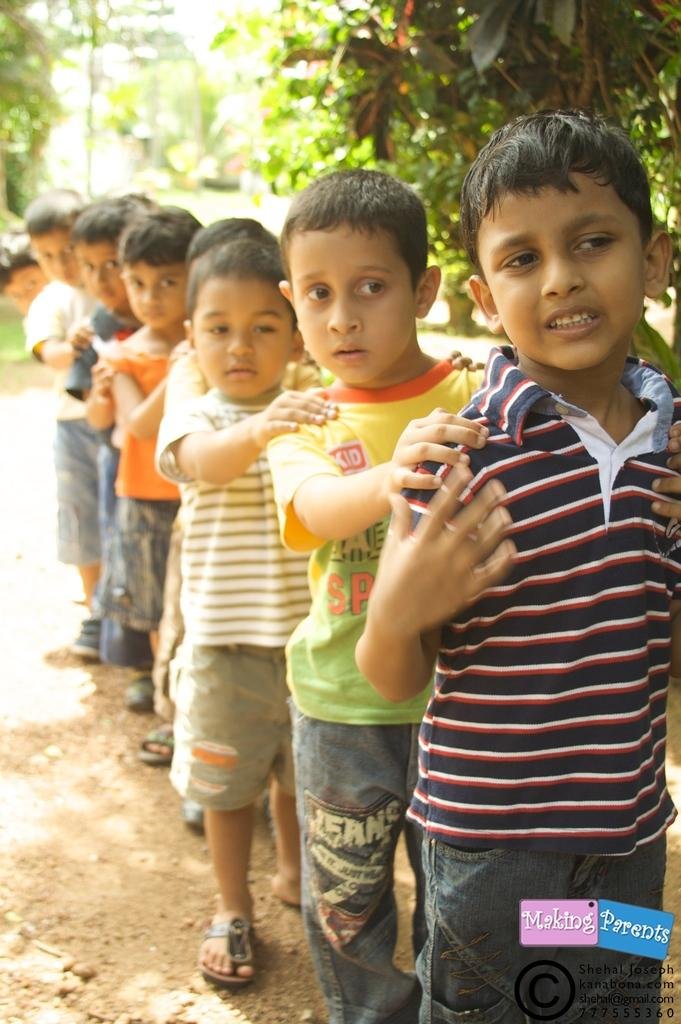What is the main subject of the image? The main subject of the image is a line of boys. Can you describe the positioning of the boys in the image? The boys are standing in a line. What can be seen in the background of the image? Trees are visible at the top of the image. What type of laborer can be seen working in the hall in the image? There is no laborer or hall present in the image; it only shows a line of boys and trees in the background. 